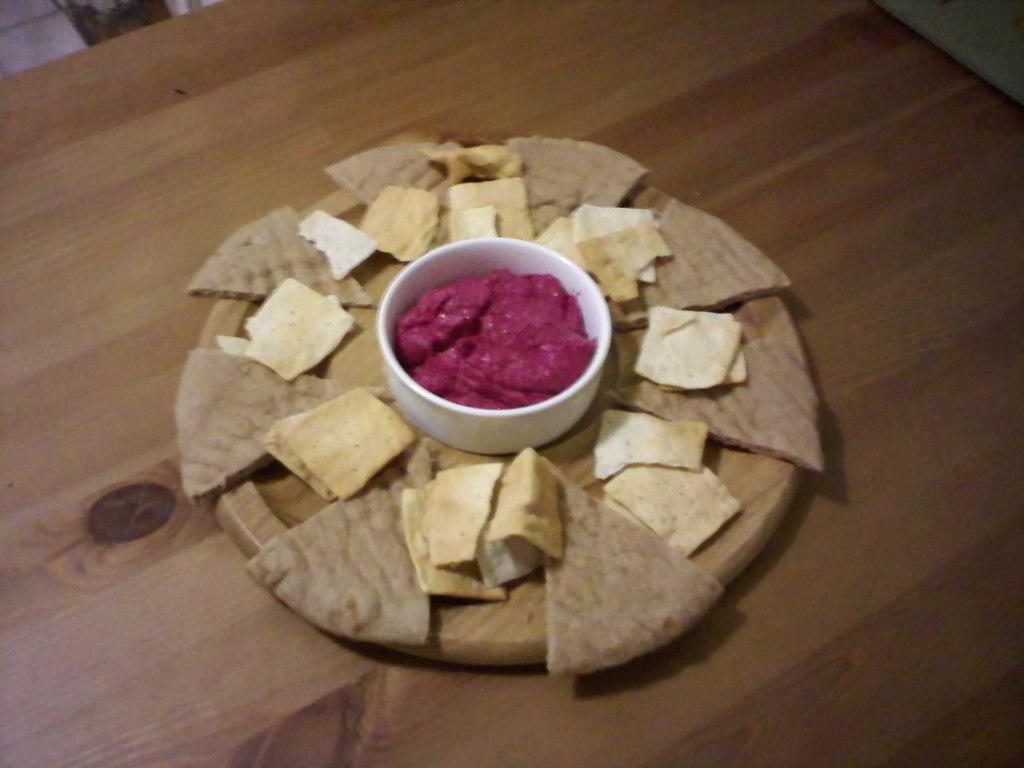Can you describe this image briefly? In this image we can see some food and bowl in a plate placed on the table. 